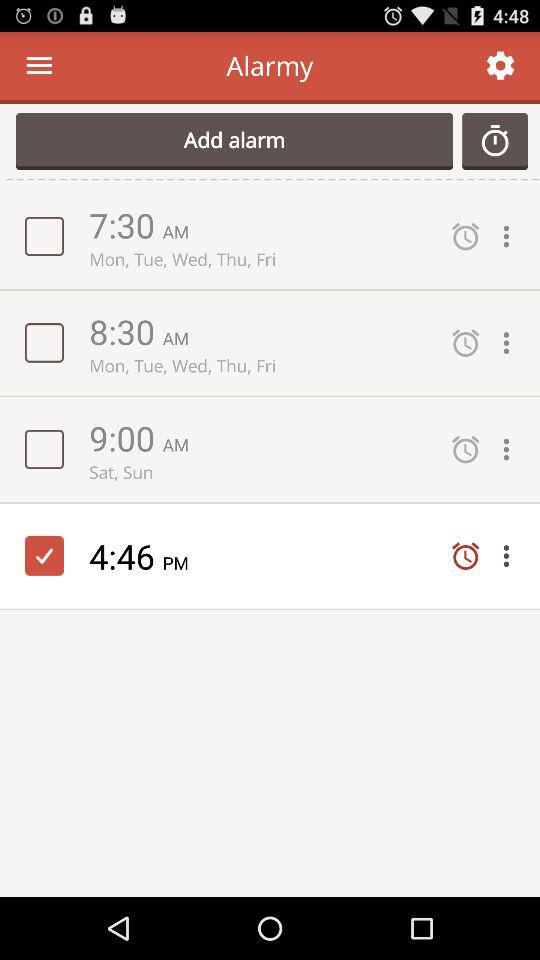What is the status of the alarm for Saturday and Sunday? The status is off. 